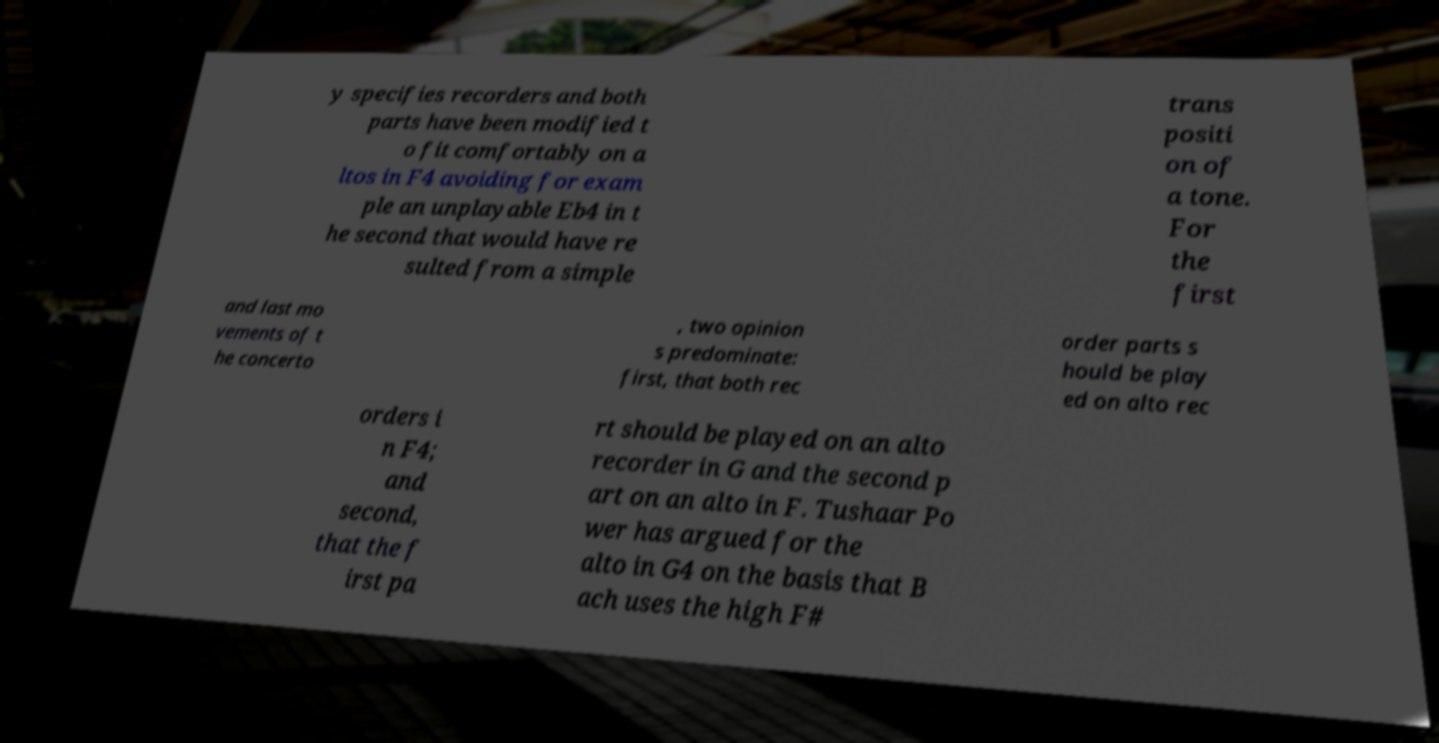Could you assist in decoding the text presented in this image and type it out clearly? y specifies recorders and both parts have been modified t o fit comfortably on a ltos in F4 avoiding for exam ple an unplayable Eb4 in t he second that would have re sulted from a simple trans positi on of a tone. For the first and last mo vements of t he concerto , two opinion s predominate: first, that both rec order parts s hould be play ed on alto rec orders i n F4; and second, that the f irst pa rt should be played on an alto recorder in G and the second p art on an alto in F. Tushaar Po wer has argued for the alto in G4 on the basis that B ach uses the high F# 